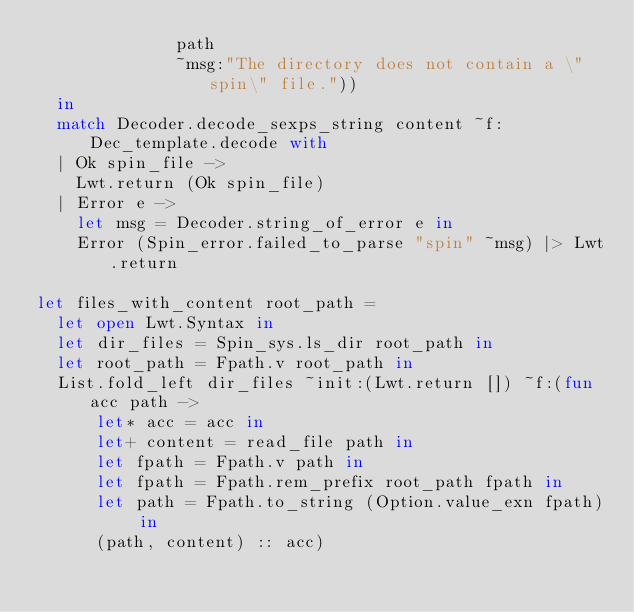<code> <loc_0><loc_0><loc_500><loc_500><_OCaml_>              path
              ~msg:"The directory does not contain a \"spin\" file."))
  in
  match Decoder.decode_sexps_string content ~f:Dec_template.decode with
  | Ok spin_file ->
    Lwt.return (Ok spin_file)
  | Error e ->
    let msg = Decoder.string_of_error e in
    Error (Spin_error.failed_to_parse "spin" ~msg) |> Lwt.return

let files_with_content root_path =
  let open Lwt.Syntax in
  let dir_files = Spin_sys.ls_dir root_path in
  let root_path = Fpath.v root_path in
  List.fold_left dir_files ~init:(Lwt.return []) ~f:(fun acc path ->
      let* acc = acc in
      let+ content = read_file path in
      let fpath = Fpath.v path in
      let fpath = Fpath.rem_prefix root_path fpath in
      let path = Fpath.to_string (Option.value_exn fpath) in
      (path, content) :: acc)
</code> 